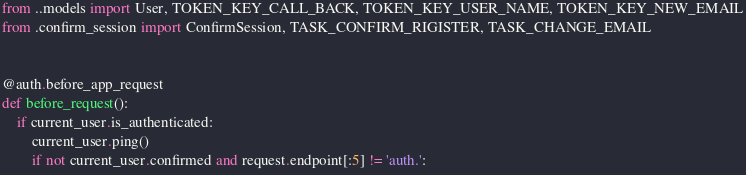<code> <loc_0><loc_0><loc_500><loc_500><_Python_>from ..models import User, TOKEN_KEY_CALL_BACK, TOKEN_KEY_USER_NAME, TOKEN_KEY_NEW_EMAIL
from .confirm_session import ConfirmSession, TASK_CONFIRM_RIGISTER, TASK_CHANGE_EMAIL


@auth.before_app_request
def before_request():
    if current_user.is_authenticated:
        current_user.ping()
        if not current_user.confirmed and request.endpoint[:5] != 'auth.':</code> 